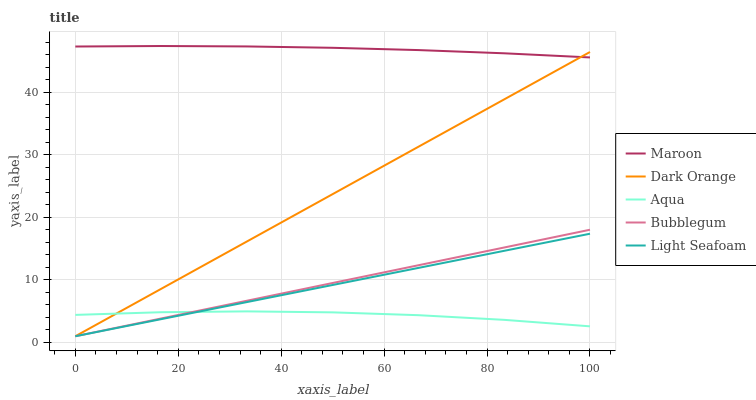Does Aqua have the minimum area under the curve?
Answer yes or no. Yes. Does Maroon have the maximum area under the curve?
Answer yes or no. Yes. Does Light Seafoam have the minimum area under the curve?
Answer yes or no. No. Does Light Seafoam have the maximum area under the curve?
Answer yes or no. No. Is Bubblegum the smoothest?
Answer yes or no. Yes. Is Aqua the roughest?
Answer yes or no. Yes. Is Light Seafoam the smoothest?
Answer yes or no. No. Is Light Seafoam the roughest?
Answer yes or no. No. Does Dark Orange have the lowest value?
Answer yes or no. Yes. Does Aqua have the lowest value?
Answer yes or no. No. Does Maroon have the highest value?
Answer yes or no. Yes. Does Light Seafoam have the highest value?
Answer yes or no. No. Is Bubblegum less than Maroon?
Answer yes or no. Yes. Is Maroon greater than Light Seafoam?
Answer yes or no. Yes. Does Dark Orange intersect Light Seafoam?
Answer yes or no. Yes. Is Dark Orange less than Light Seafoam?
Answer yes or no. No. Is Dark Orange greater than Light Seafoam?
Answer yes or no. No. Does Bubblegum intersect Maroon?
Answer yes or no. No. 